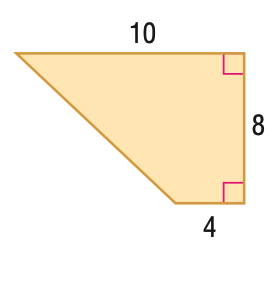Answer the mathemtical geometry problem and directly provide the correct option letter.
Question: Find the area of the figure.
Choices: A: 24 B: 28 C: 56 D: 112 C 